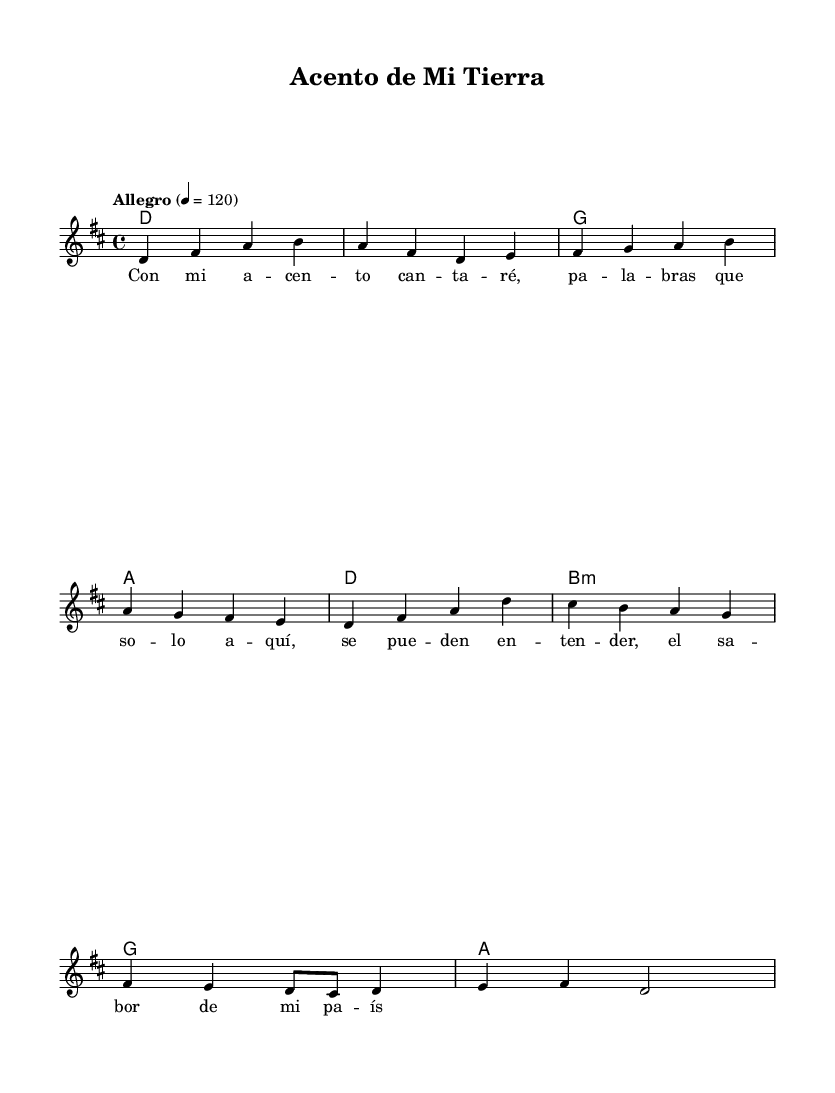What is the key signature of this music? The key signature indicates D major, which has two sharps (F# and C#). This can be seen at the beginning of the score where the key signature notation is displayed.
Answer: D major What is the time signature of the piece? The time signature is shown as 4/4, which means there are four beats in a measure and a quarter note gets one beat. This can be found at the beginning of the score right after the key signature.
Answer: 4/4 What tempo marking is indicated in the score? The tempo marking states "Allegro" and defines a specific beats per minute (120). This is specified at the beginning of the score, providing guidance on the speed of the piece.
Answer: Allegro How many measures are in the melody section? Counting the sequences of notes in the melody, there are a total of 8 measures (each separated by a vertical line). The melody lines can be visually counted measure by measure.
Answer: 8 Which chord follows after the D major chord? The chord that follows the D major chord is G major, as indicated in the chord progression specified in the harmonies section. By following the chord pattern, G major can be identified directly after D.
Answer: G What is the first lyric of the song? The first lyric of the song is "Con," which appears at the beginning of the lyrics section beneath the melody. By checking the lyric line directly under the first notes, "Con" can be identified.
Answer: Con What style of music does this piece represent? The music style depicted in this piece is Pop, as indicated by the contemporary elements and settings, such as upbeat tempos and relatable lyrics that often characterize pop songs. This is inferred from the overall structure and context of the song.
Answer: Pop 